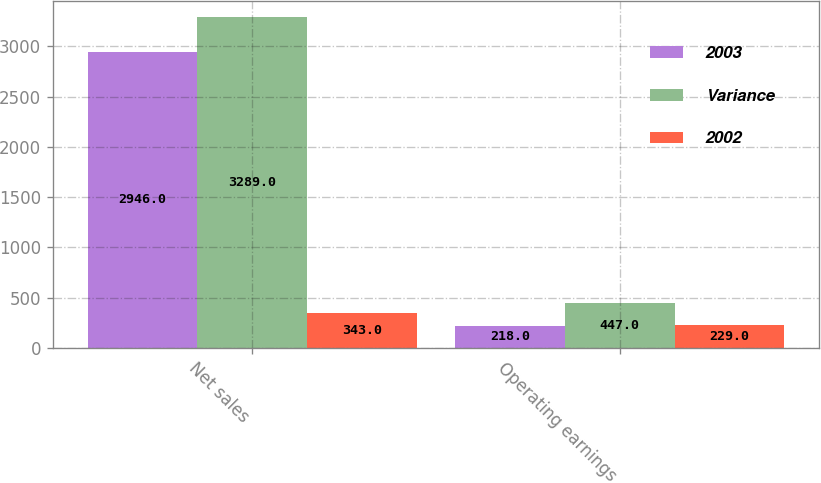<chart> <loc_0><loc_0><loc_500><loc_500><stacked_bar_chart><ecel><fcel>Net sales<fcel>Operating earnings<nl><fcel>2003<fcel>2946<fcel>218<nl><fcel>Variance<fcel>3289<fcel>447<nl><fcel>2002<fcel>343<fcel>229<nl></chart> 